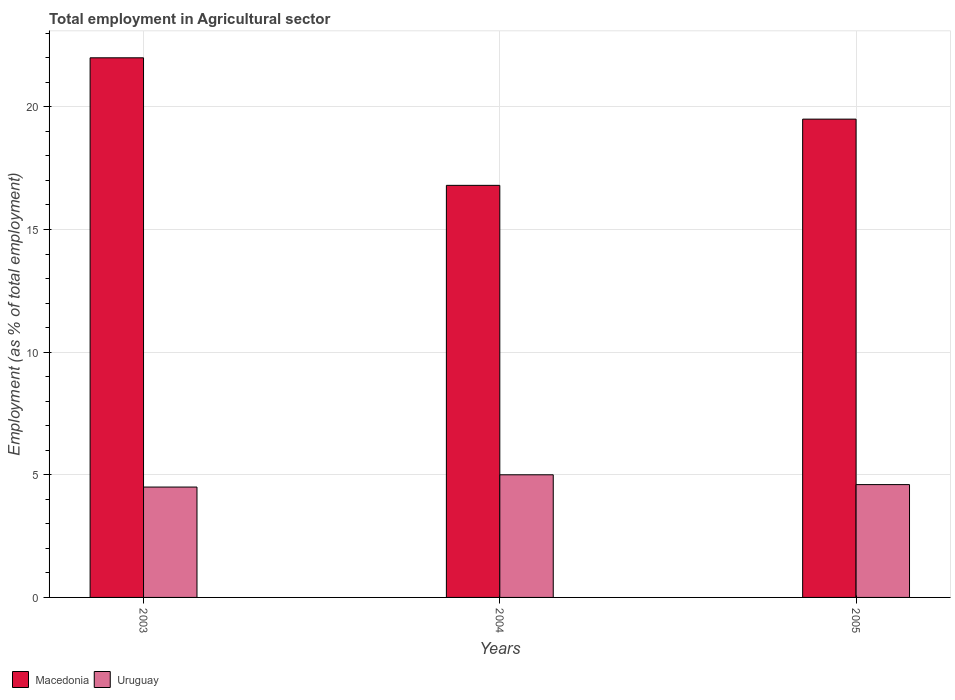How many groups of bars are there?
Offer a very short reply. 3. Are the number of bars per tick equal to the number of legend labels?
Offer a very short reply. Yes. Are the number of bars on each tick of the X-axis equal?
Give a very brief answer. Yes. In how many cases, is the number of bars for a given year not equal to the number of legend labels?
Offer a terse response. 0. What is the employment in agricultural sector in Macedonia in 2004?
Offer a terse response. 16.8. Across all years, what is the maximum employment in agricultural sector in Uruguay?
Ensure brevity in your answer.  5. In which year was the employment in agricultural sector in Uruguay maximum?
Provide a succinct answer. 2004. In which year was the employment in agricultural sector in Uruguay minimum?
Offer a terse response. 2003. What is the total employment in agricultural sector in Macedonia in the graph?
Your answer should be very brief. 58.3. What is the difference between the employment in agricultural sector in Uruguay in 2003 and that in 2005?
Keep it short and to the point. -0.1. What is the average employment in agricultural sector in Macedonia per year?
Offer a very short reply. 19.43. In the year 2005, what is the difference between the employment in agricultural sector in Macedonia and employment in agricultural sector in Uruguay?
Keep it short and to the point. 14.9. In how many years, is the employment in agricultural sector in Macedonia greater than 14 %?
Ensure brevity in your answer.  3. What is the ratio of the employment in agricultural sector in Uruguay in 2003 to that in 2004?
Give a very brief answer. 0.9. What is the difference between the highest and the lowest employment in agricultural sector in Macedonia?
Offer a terse response. 5.2. In how many years, is the employment in agricultural sector in Uruguay greater than the average employment in agricultural sector in Uruguay taken over all years?
Your answer should be compact. 1. Is the sum of the employment in agricultural sector in Macedonia in 2003 and 2005 greater than the maximum employment in agricultural sector in Uruguay across all years?
Your answer should be compact. Yes. What does the 1st bar from the left in 2004 represents?
Offer a terse response. Macedonia. What does the 1st bar from the right in 2003 represents?
Provide a short and direct response. Uruguay. How many bars are there?
Provide a short and direct response. 6. Are all the bars in the graph horizontal?
Ensure brevity in your answer.  No. Where does the legend appear in the graph?
Your response must be concise. Bottom left. How many legend labels are there?
Make the answer very short. 2. How are the legend labels stacked?
Provide a short and direct response. Horizontal. What is the title of the graph?
Offer a terse response. Total employment in Agricultural sector. Does "Low income" appear as one of the legend labels in the graph?
Provide a short and direct response. No. What is the label or title of the X-axis?
Your response must be concise. Years. What is the label or title of the Y-axis?
Keep it short and to the point. Employment (as % of total employment). What is the Employment (as % of total employment) of Macedonia in 2003?
Provide a succinct answer. 22. What is the Employment (as % of total employment) of Uruguay in 2003?
Provide a succinct answer. 4.5. What is the Employment (as % of total employment) in Macedonia in 2004?
Your answer should be compact. 16.8. What is the Employment (as % of total employment) of Macedonia in 2005?
Provide a short and direct response. 19.5. What is the Employment (as % of total employment) in Uruguay in 2005?
Your response must be concise. 4.6. Across all years, what is the minimum Employment (as % of total employment) in Macedonia?
Keep it short and to the point. 16.8. What is the total Employment (as % of total employment) in Macedonia in the graph?
Make the answer very short. 58.3. What is the difference between the Employment (as % of total employment) of Uruguay in 2003 and that in 2004?
Give a very brief answer. -0.5. What is the difference between the Employment (as % of total employment) of Uruguay in 2003 and that in 2005?
Offer a terse response. -0.1. What is the difference between the Employment (as % of total employment) of Macedonia in 2004 and that in 2005?
Offer a very short reply. -2.7. What is the difference between the Employment (as % of total employment) in Macedonia in 2003 and the Employment (as % of total employment) in Uruguay in 2004?
Your answer should be very brief. 17. What is the difference between the Employment (as % of total employment) of Macedonia in 2003 and the Employment (as % of total employment) of Uruguay in 2005?
Your answer should be very brief. 17.4. What is the average Employment (as % of total employment) in Macedonia per year?
Offer a very short reply. 19.43. What is the average Employment (as % of total employment) in Uruguay per year?
Keep it short and to the point. 4.7. In the year 2004, what is the difference between the Employment (as % of total employment) of Macedonia and Employment (as % of total employment) of Uruguay?
Your response must be concise. 11.8. What is the ratio of the Employment (as % of total employment) of Macedonia in 2003 to that in 2004?
Offer a very short reply. 1.31. What is the ratio of the Employment (as % of total employment) in Uruguay in 2003 to that in 2004?
Your answer should be very brief. 0.9. What is the ratio of the Employment (as % of total employment) in Macedonia in 2003 to that in 2005?
Offer a very short reply. 1.13. What is the ratio of the Employment (as % of total employment) in Uruguay in 2003 to that in 2005?
Ensure brevity in your answer.  0.98. What is the ratio of the Employment (as % of total employment) of Macedonia in 2004 to that in 2005?
Keep it short and to the point. 0.86. What is the ratio of the Employment (as % of total employment) of Uruguay in 2004 to that in 2005?
Ensure brevity in your answer.  1.09. What is the difference between the highest and the second highest Employment (as % of total employment) in Uruguay?
Make the answer very short. 0.4. What is the difference between the highest and the lowest Employment (as % of total employment) of Macedonia?
Keep it short and to the point. 5.2. 